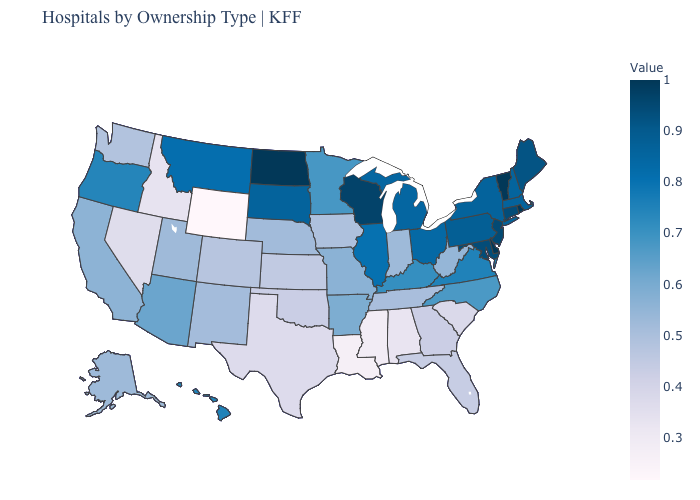Among the states that border Massachusetts , does Connecticut have the highest value?
Write a very short answer. No. Is the legend a continuous bar?
Give a very brief answer. Yes. 